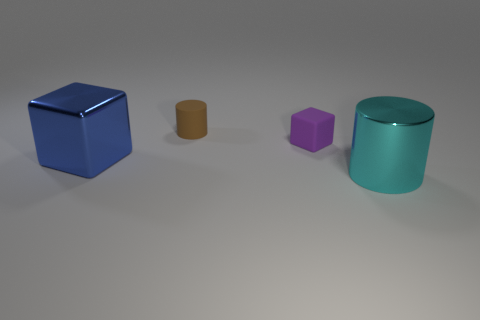Subtract 1 cylinders. How many cylinders are left? 1 Subtract all blue blocks. How many blocks are left? 1 Subtract all purple blocks. How many blue cylinders are left? 0 Add 3 tiny brown objects. How many tiny brown objects exist? 4 Add 1 big cylinders. How many objects exist? 5 Subtract 0 green cylinders. How many objects are left? 4 Subtract all green cylinders. Subtract all blue cubes. How many cylinders are left? 2 Subtract all purple objects. Subtract all green metal things. How many objects are left? 3 Add 3 cyan metal objects. How many cyan metal objects are left? 4 